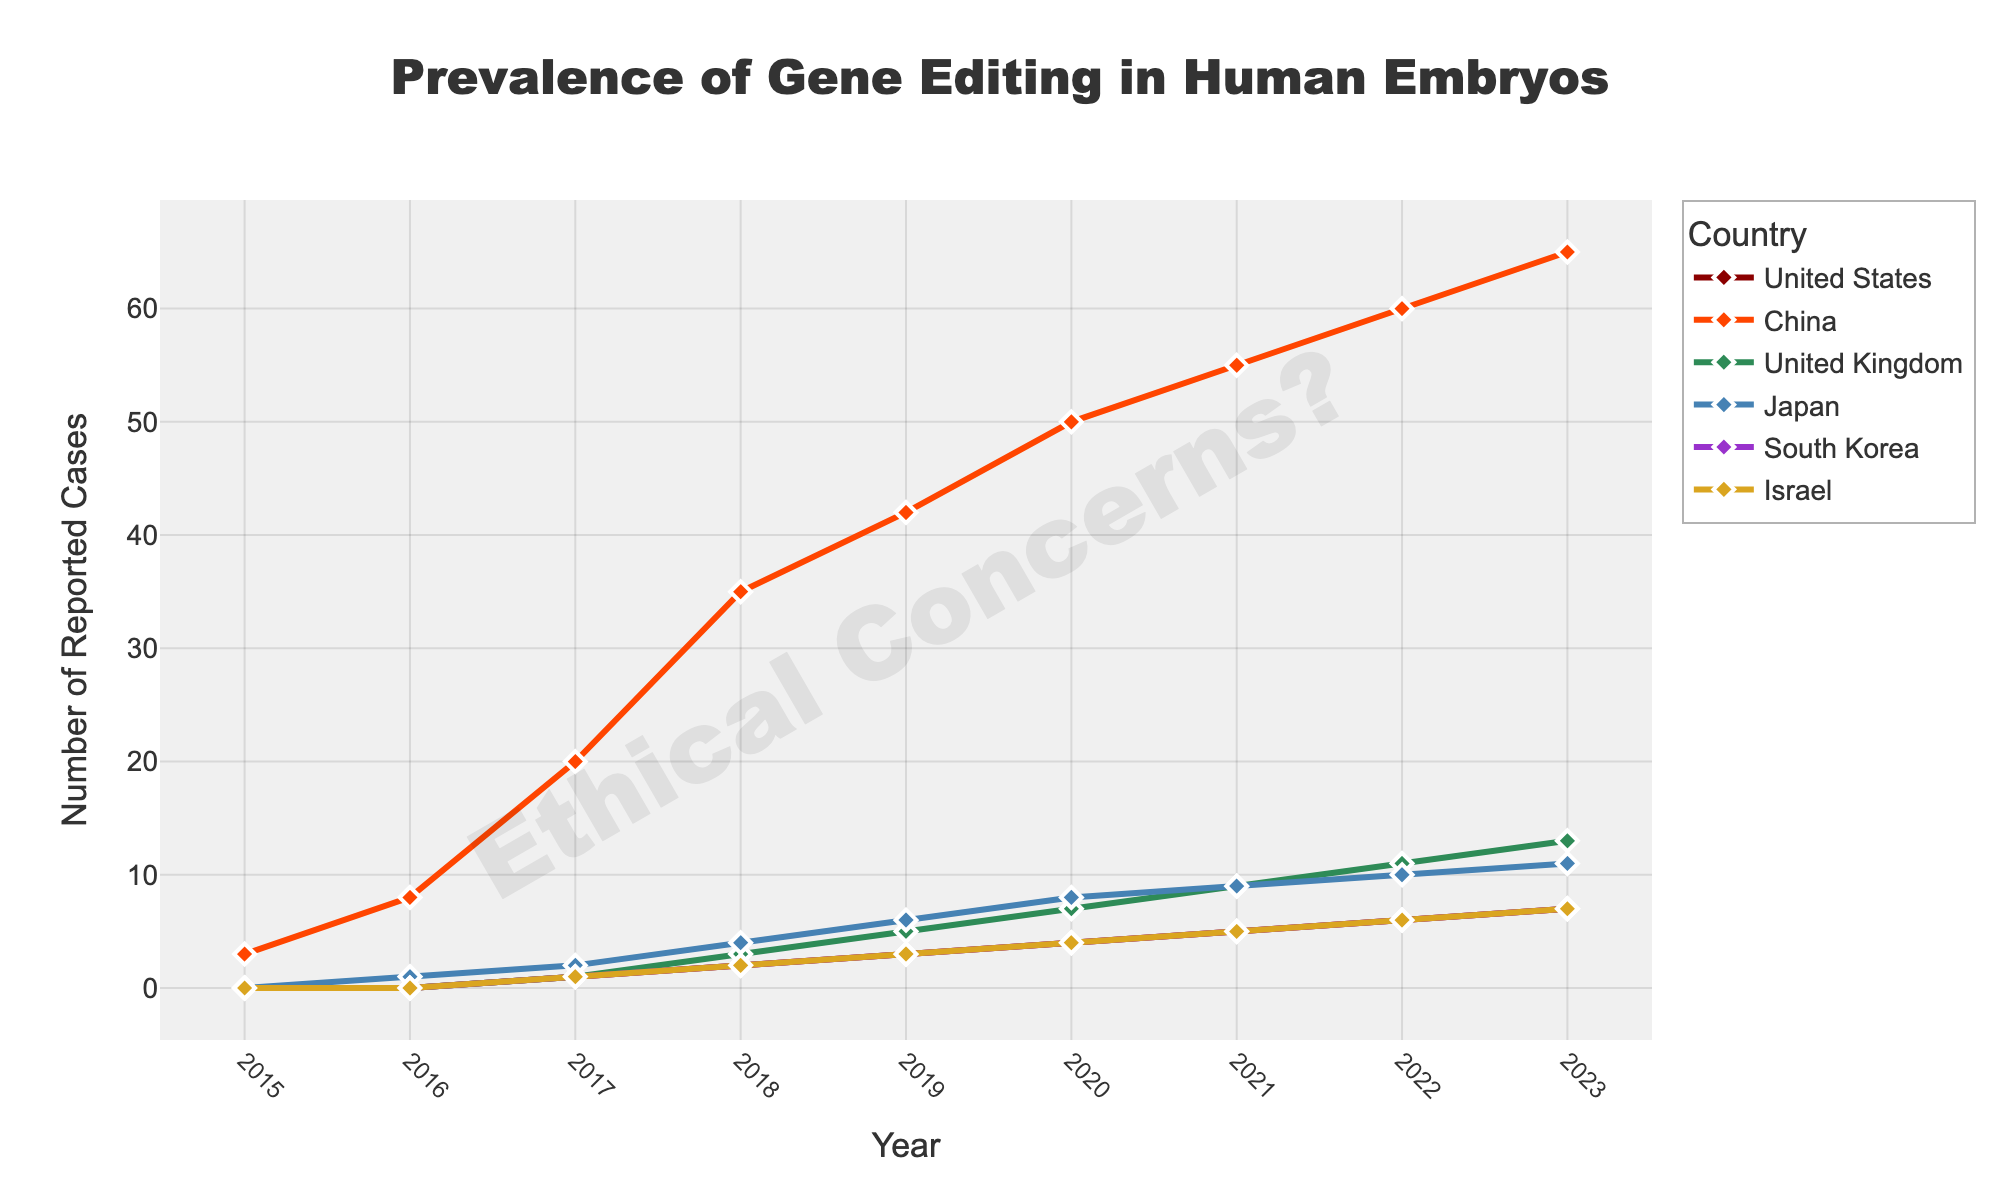What is the general trend of gene editing prevalence in China between 2016 and 2023? To determine the trend, we look at the data for China between 2016 and 2023. The numbers are consistently increasing each year (8 in 2016 to 65 in 2023). This upward trend indicates that the prevalence of gene editing in China has been increasing steadily over the years.
Answer: Increasing steadily Which country had the highest prevalence of gene editing in human embryos in 2019? To find out which country had the highest prevalence in 2019, we compare the values across all countries for that year. According to the plot, China had the highest number of reported cases in 2019, with a value of 42.
Answer: China By how much did the United States' reported cases of gene editing in human embryos increase from 2016 to 2020? To find the increase, we note the values for the United States in 2016 and 2020, which are 0 and 4, respectively. Subtract the 2016 value from the 2020 value to calculate the increase: 4 - 0 = 4 cases.
Answer: 4 cases Identify the two countries with the least number of reported gene editing cases in 2017 and compare their total to the number reported in China in the same year. The countries with the least reported cases in 2017 are the United States, United Kingdom, South Korea, and Israel, each with 1 case. China reported 20 cases. Summing the minimum cases, (1 + 1 + 1 + 1) = 4, which is much lower than China's 20 cases.
Answer: Total of 4 cases vs 20 cases Across all years shown in the figure, which country shows a linear increase in the prevalence of gene editing in human embryos? A linear increase means the number of reported cases grows by a consistent amount each year. Looking at the series, the United Kingdom has consistently increased by a set amount each year (e.g., 0, 1, 1, 2, etc.), forming a linear pattern on the graph.
Answer: United Kingdom What is the average number of gene-editing cases reported for Japan from 2017 to 2023? To find the average, sum the values for Japan from 2017 to 2023 (2+4+6+8+9+10+11 = 50) and divide by the number of years (7): 50/7 ≈ 7.14.
Answer: Approximately 7.14 cases How did South Korea's gene-editing cases compare with Israel's cases in 2023? To compare the values for 2023, note that both South Korea and Israel had 7 reported cases. Therefore, South Korea and Israel had the same number of reported cases in 2023.
Answer: Same What color is the line representing the prevalence of gene editing in human embryos in the United States? From the description of the colors used, the United States is represented by a dark red line.
Answer: Dark red Between 2018 and 2022, which country saw the greatest increase in reported gene-editing cases? To determine the largest increase, calculate the difference for each country between 2018 and 2022: China (60-35=25), Japan (10-4=6), South Korea (6-2=4), Israel (6-2=4), UK (11-3=8), and the US (6-2=4). China had the largest increase (25 cases).
Answer: China What visual element is used to highlight ethical concerns on the figure? The figure includes a watermark with the text "Ethical Concerns?" displayed diagonally across the plot area.
Answer: Watermark with text 